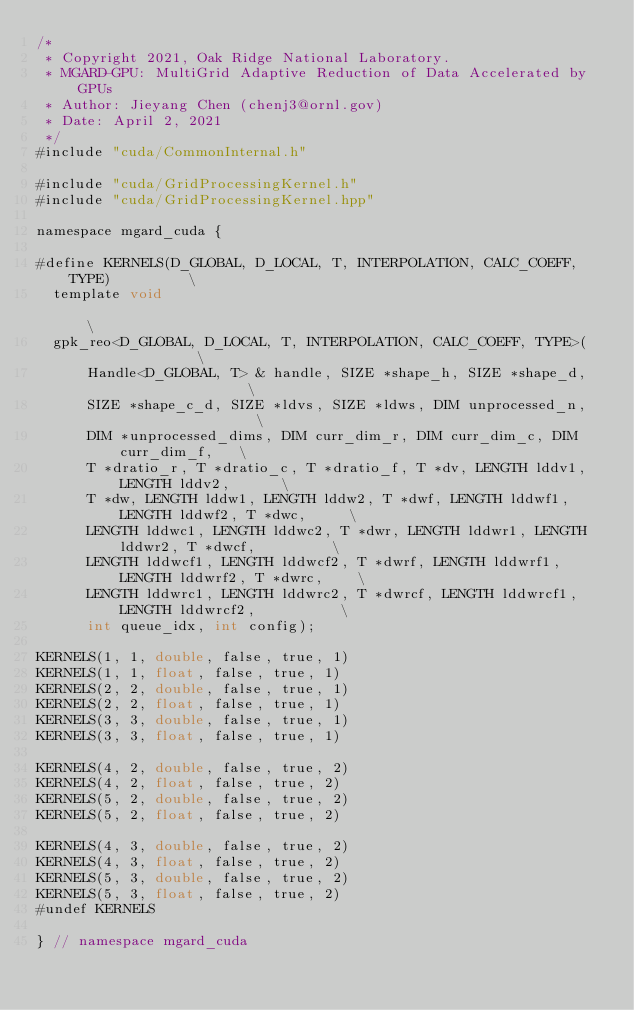<code> <loc_0><loc_0><loc_500><loc_500><_Cuda_>/*
 * Copyright 2021, Oak Ridge National Laboratory.
 * MGARD-GPU: MultiGrid Adaptive Reduction of Data Accelerated by GPUs
 * Author: Jieyang Chen (chenj3@ornl.gov)
 * Date: April 2, 2021
 */
#include "cuda/CommonInternal.h"
 
#include "cuda/GridProcessingKernel.h"
#include "cuda/GridProcessingKernel.hpp"

namespace mgard_cuda {

#define KERNELS(D_GLOBAL, D_LOCAL, T, INTERPOLATION, CALC_COEFF, TYPE)         \
  template void                                                                \
  gpk_reo<D_GLOBAL, D_LOCAL, T, INTERPOLATION, CALC_COEFF, TYPE>(              \
      Handle<D_GLOBAL, T> & handle, SIZE *shape_h, SIZE *shape_d,                \
      SIZE *shape_c_d, SIZE *ldvs, SIZE *ldws, DIM unprocessed_n,                 \
      DIM *unprocessed_dims, DIM curr_dim_r, DIM curr_dim_c, DIM curr_dim_f,   \
      T *dratio_r, T *dratio_c, T *dratio_f, T *dv, LENGTH lddv1, LENGTH lddv2,      \
      T *dw, LENGTH lddw1, LENGTH lddw2, T *dwf, LENGTH lddwf1, LENGTH lddwf2, T *dwc,     \
      LENGTH lddwc1, LENGTH lddwc2, T *dwr, LENGTH lddwr1, LENGTH lddwr2, T *dwcf,         \
      LENGTH lddwcf1, LENGTH lddwcf2, T *dwrf, LENGTH lddwrf1, LENGTH lddwrf2, T *dwrc,    \
      LENGTH lddwrc1, LENGTH lddwrc2, T *dwrcf, LENGTH lddwrcf1, LENGTH lddwrcf2,          \
      int queue_idx, int config);

KERNELS(1, 1, double, false, true, 1)
KERNELS(1, 1, float, false, true, 1)
KERNELS(2, 2, double, false, true, 1)
KERNELS(2, 2, float, false, true, 1)
KERNELS(3, 3, double, false, true, 1)
KERNELS(3, 3, float, false, true, 1)

KERNELS(4, 2, double, false, true, 2)
KERNELS(4, 2, float, false, true, 2)
KERNELS(5, 2, double, false, true, 2)
KERNELS(5, 2, float, false, true, 2)

KERNELS(4, 3, double, false, true, 2)
KERNELS(4, 3, float, false, true, 2)
KERNELS(5, 3, double, false, true, 2)
KERNELS(5, 3, float, false, true, 2)
#undef KERNELS

} // namespace mgard_cuda</code> 